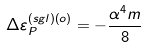Convert formula to latex. <formula><loc_0><loc_0><loc_500><loc_500>\Delta \varepsilon _ { P } ^ { ( s g l ) \left ( o \right ) } = - \frac { \alpha ^ { 4 } m } { 8 }</formula> 